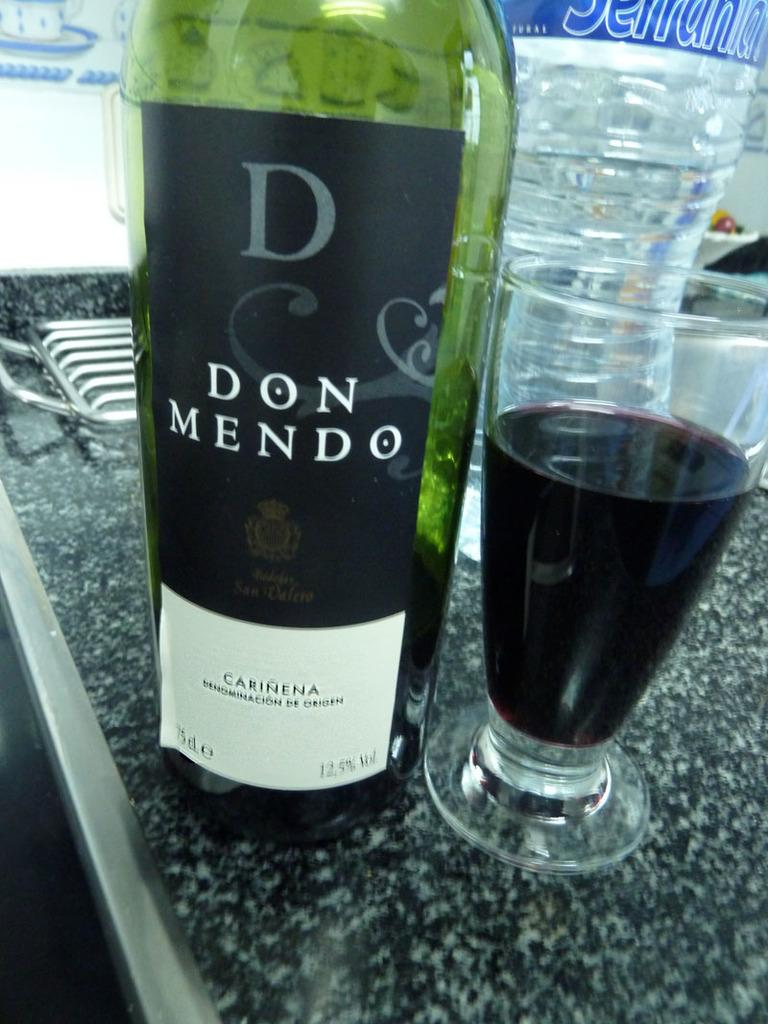<image>
Summarize the visual content of the image. A GREEN BOTTLE OF DON MENDO WINE AND A GLASS OF WINE TO THE RIGHT OF IT. 